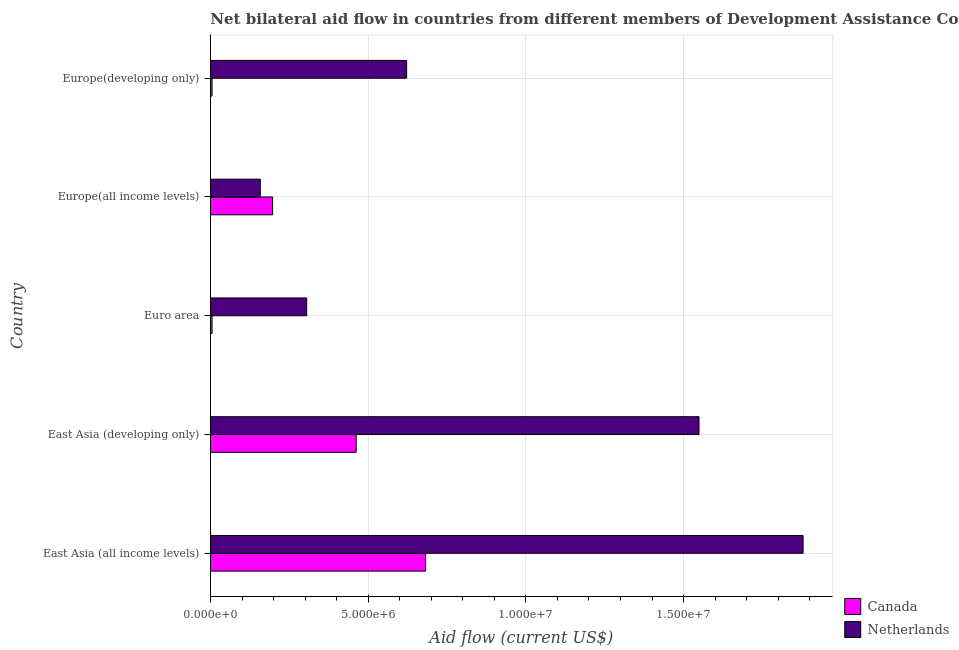How many groups of bars are there?
Offer a terse response. 5. Are the number of bars per tick equal to the number of legend labels?
Provide a succinct answer. Yes. What is the label of the 2nd group of bars from the top?
Ensure brevity in your answer.  Europe(all income levels). What is the amount of aid given by canada in Europe(all income levels)?
Your answer should be compact. 1.97e+06. Across all countries, what is the maximum amount of aid given by netherlands?
Ensure brevity in your answer.  1.88e+07. Across all countries, what is the minimum amount of aid given by netherlands?
Give a very brief answer. 1.58e+06. In which country was the amount of aid given by canada maximum?
Your response must be concise. East Asia (all income levels). In which country was the amount of aid given by netherlands minimum?
Offer a very short reply. Europe(all income levels). What is the total amount of aid given by netherlands in the graph?
Offer a very short reply. 4.51e+07. What is the difference between the amount of aid given by canada in East Asia (developing only) and that in Europe(developing only)?
Ensure brevity in your answer.  4.57e+06. What is the difference between the amount of aid given by canada in Europe(all income levels) and the amount of aid given by netherlands in East Asia (all income levels)?
Provide a short and direct response. -1.68e+07. What is the average amount of aid given by netherlands per country?
Give a very brief answer. 9.03e+06. In how many countries, is the amount of aid given by netherlands greater than 3000000 US$?
Your answer should be very brief. 4. What is the ratio of the amount of aid given by netherlands in East Asia (developing only) to that in Europe(all income levels)?
Ensure brevity in your answer.  9.8. Is the amount of aid given by canada in East Asia (all income levels) less than that in Euro area?
Provide a succinct answer. No. What is the difference between the highest and the second highest amount of aid given by canada?
Make the answer very short. 2.20e+06. What is the difference between the highest and the lowest amount of aid given by canada?
Offer a very short reply. 6.77e+06. What does the 1st bar from the top in Europe(all income levels) represents?
Offer a terse response. Netherlands. How many bars are there?
Make the answer very short. 10. How many countries are there in the graph?
Provide a succinct answer. 5. Are the values on the major ticks of X-axis written in scientific E-notation?
Make the answer very short. Yes. How many legend labels are there?
Ensure brevity in your answer.  2. How are the legend labels stacked?
Offer a terse response. Vertical. What is the title of the graph?
Your answer should be very brief. Net bilateral aid flow in countries from different members of Development Assistance Committee. What is the label or title of the X-axis?
Your answer should be very brief. Aid flow (current US$). What is the label or title of the Y-axis?
Provide a short and direct response. Country. What is the Aid flow (current US$) in Canada in East Asia (all income levels)?
Your response must be concise. 6.82e+06. What is the Aid flow (current US$) in Netherlands in East Asia (all income levels)?
Your response must be concise. 1.88e+07. What is the Aid flow (current US$) in Canada in East Asia (developing only)?
Offer a very short reply. 4.62e+06. What is the Aid flow (current US$) in Netherlands in East Asia (developing only)?
Offer a terse response. 1.55e+07. What is the Aid flow (current US$) of Canada in Euro area?
Provide a short and direct response. 5.00e+04. What is the Aid flow (current US$) in Netherlands in Euro area?
Your answer should be compact. 3.05e+06. What is the Aid flow (current US$) in Canada in Europe(all income levels)?
Give a very brief answer. 1.97e+06. What is the Aid flow (current US$) in Netherlands in Europe(all income levels)?
Keep it short and to the point. 1.58e+06. What is the Aid flow (current US$) in Netherlands in Europe(developing only)?
Your response must be concise. 6.22e+06. Across all countries, what is the maximum Aid flow (current US$) in Canada?
Keep it short and to the point. 6.82e+06. Across all countries, what is the maximum Aid flow (current US$) in Netherlands?
Offer a terse response. 1.88e+07. Across all countries, what is the minimum Aid flow (current US$) in Netherlands?
Offer a terse response. 1.58e+06. What is the total Aid flow (current US$) of Canada in the graph?
Your response must be concise. 1.35e+07. What is the total Aid flow (current US$) in Netherlands in the graph?
Your answer should be very brief. 4.51e+07. What is the difference between the Aid flow (current US$) in Canada in East Asia (all income levels) and that in East Asia (developing only)?
Your answer should be compact. 2.20e+06. What is the difference between the Aid flow (current US$) in Netherlands in East Asia (all income levels) and that in East Asia (developing only)?
Provide a succinct answer. 3.30e+06. What is the difference between the Aid flow (current US$) in Canada in East Asia (all income levels) and that in Euro area?
Offer a terse response. 6.77e+06. What is the difference between the Aid flow (current US$) in Netherlands in East Asia (all income levels) and that in Euro area?
Offer a very short reply. 1.57e+07. What is the difference between the Aid flow (current US$) in Canada in East Asia (all income levels) and that in Europe(all income levels)?
Offer a terse response. 4.85e+06. What is the difference between the Aid flow (current US$) of Netherlands in East Asia (all income levels) and that in Europe(all income levels)?
Your response must be concise. 1.72e+07. What is the difference between the Aid flow (current US$) in Canada in East Asia (all income levels) and that in Europe(developing only)?
Give a very brief answer. 6.77e+06. What is the difference between the Aid flow (current US$) in Netherlands in East Asia (all income levels) and that in Europe(developing only)?
Offer a very short reply. 1.26e+07. What is the difference between the Aid flow (current US$) in Canada in East Asia (developing only) and that in Euro area?
Your response must be concise. 4.57e+06. What is the difference between the Aid flow (current US$) of Netherlands in East Asia (developing only) and that in Euro area?
Provide a short and direct response. 1.24e+07. What is the difference between the Aid flow (current US$) in Canada in East Asia (developing only) and that in Europe(all income levels)?
Make the answer very short. 2.65e+06. What is the difference between the Aid flow (current US$) of Netherlands in East Asia (developing only) and that in Europe(all income levels)?
Offer a terse response. 1.39e+07. What is the difference between the Aid flow (current US$) in Canada in East Asia (developing only) and that in Europe(developing only)?
Ensure brevity in your answer.  4.57e+06. What is the difference between the Aid flow (current US$) of Netherlands in East Asia (developing only) and that in Europe(developing only)?
Your response must be concise. 9.27e+06. What is the difference between the Aid flow (current US$) in Canada in Euro area and that in Europe(all income levels)?
Offer a very short reply. -1.92e+06. What is the difference between the Aid flow (current US$) in Netherlands in Euro area and that in Europe(all income levels)?
Offer a terse response. 1.47e+06. What is the difference between the Aid flow (current US$) in Canada in Euro area and that in Europe(developing only)?
Offer a terse response. 0. What is the difference between the Aid flow (current US$) of Netherlands in Euro area and that in Europe(developing only)?
Your response must be concise. -3.17e+06. What is the difference between the Aid flow (current US$) in Canada in Europe(all income levels) and that in Europe(developing only)?
Make the answer very short. 1.92e+06. What is the difference between the Aid flow (current US$) in Netherlands in Europe(all income levels) and that in Europe(developing only)?
Offer a terse response. -4.64e+06. What is the difference between the Aid flow (current US$) of Canada in East Asia (all income levels) and the Aid flow (current US$) of Netherlands in East Asia (developing only)?
Your answer should be compact. -8.67e+06. What is the difference between the Aid flow (current US$) in Canada in East Asia (all income levels) and the Aid flow (current US$) in Netherlands in Euro area?
Provide a succinct answer. 3.77e+06. What is the difference between the Aid flow (current US$) in Canada in East Asia (all income levels) and the Aid flow (current US$) in Netherlands in Europe(all income levels)?
Your answer should be very brief. 5.24e+06. What is the difference between the Aid flow (current US$) of Canada in East Asia (all income levels) and the Aid flow (current US$) of Netherlands in Europe(developing only)?
Make the answer very short. 6.00e+05. What is the difference between the Aid flow (current US$) in Canada in East Asia (developing only) and the Aid flow (current US$) in Netherlands in Euro area?
Provide a short and direct response. 1.57e+06. What is the difference between the Aid flow (current US$) of Canada in East Asia (developing only) and the Aid flow (current US$) of Netherlands in Europe(all income levels)?
Give a very brief answer. 3.04e+06. What is the difference between the Aid flow (current US$) in Canada in East Asia (developing only) and the Aid flow (current US$) in Netherlands in Europe(developing only)?
Your answer should be very brief. -1.60e+06. What is the difference between the Aid flow (current US$) of Canada in Euro area and the Aid flow (current US$) of Netherlands in Europe(all income levels)?
Your answer should be compact. -1.53e+06. What is the difference between the Aid flow (current US$) in Canada in Euro area and the Aid flow (current US$) in Netherlands in Europe(developing only)?
Give a very brief answer. -6.17e+06. What is the difference between the Aid flow (current US$) in Canada in Europe(all income levels) and the Aid flow (current US$) in Netherlands in Europe(developing only)?
Make the answer very short. -4.25e+06. What is the average Aid flow (current US$) of Canada per country?
Ensure brevity in your answer.  2.70e+06. What is the average Aid flow (current US$) in Netherlands per country?
Make the answer very short. 9.03e+06. What is the difference between the Aid flow (current US$) of Canada and Aid flow (current US$) of Netherlands in East Asia (all income levels)?
Make the answer very short. -1.20e+07. What is the difference between the Aid flow (current US$) in Canada and Aid flow (current US$) in Netherlands in East Asia (developing only)?
Provide a short and direct response. -1.09e+07. What is the difference between the Aid flow (current US$) in Canada and Aid flow (current US$) in Netherlands in Euro area?
Keep it short and to the point. -3.00e+06. What is the difference between the Aid flow (current US$) in Canada and Aid flow (current US$) in Netherlands in Europe(all income levels)?
Offer a very short reply. 3.90e+05. What is the difference between the Aid flow (current US$) of Canada and Aid flow (current US$) of Netherlands in Europe(developing only)?
Your answer should be compact. -6.17e+06. What is the ratio of the Aid flow (current US$) in Canada in East Asia (all income levels) to that in East Asia (developing only)?
Provide a succinct answer. 1.48. What is the ratio of the Aid flow (current US$) of Netherlands in East Asia (all income levels) to that in East Asia (developing only)?
Ensure brevity in your answer.  1.21. What is the ratio of the Aid flow (current US$) in Canada in East Asia (all income levels) to that in Euro area?
Provide a succinct answer. 136.4. What is the ratio of the Aid flow (current US$) in Netherlands in East Asia (all income levels) to that in Euro area?
Offer a very short reply. 6.16. What is the ratio of the Aid flow (current US$) in Canada in East Asia (all income levels) to that in Europe(all income levels)?
Offer a terse response. 3.46. What is the ratio of the Aid flow (current US$) of Netherlands in East Asia (all income levels) to that in Europe(all income levels)?
Provide a succinct answer. 11.89. What is the ratio of the Aid flow (current US$) of Canada in East Asia (all income levels) to that in Europe(developing only)?
Give a very brief answer. 136.4. What is the ratio of the Aid flow (current US$) in Netherlands in East Asia (all income levels) to that in Europe(developing only)?
Make the answer very short. 3.02. What is the ratio of the Aid flow (current US$) in Canada in East Asia (developing only) to that in Euro area?
Give a very brief answer. 92.4. What is the ratio of the Aid flow (current US$) in Netherlands in East Asia (developing only) to that in Euro area?
Make the answer very short. 5.08. What is the ratio of the Aid flow (current US$) of Canada in East Asia (developing only) to that in Europe(all income levels)?
Give a very brief answer. 2.35. What is the ratio of the Aid flow (current US$) of Netherlands in East Asia (developing only) to that in Europe(all income levels)?
Provide a short and direct response. 9.8. What is the ratio of the Aid flow (current US$) of Canada in East Asia (developing only) to that in Europe(developing only)?
Provide a short and direct response. 92.4. What is the ratio of the Aid flow (current US$) of Netherlands in East Asia (developing only) to that in Europe(developing only)?
Keep it short and to the point. 2.49. What is the ratio of the Aid flow (current US$) in Canada in Euro area to that in Europe(all income levels)?
Give a very brief answer. 0.03. What is the ratio of the Aid flow (current US$) of Netherlands in Euro area to that in Europe(all income levels)?
Your answer should be very brief. 1.93. What is the ratio of the Aid flow (current US$) of Canada in Euro area to that in Europe(developing only)?
Your answer should be compact. 1. What is the ratio of the Aid flow (current US$) of Netherlands in Euro area to that in Europe(developing only)?
Provide a short and direct response. 0.49. What is the ratio of the Aid flow (current US$) in Canada in Europe(all income levels) to that in Europe(developing only)?
Your response must be concise. 39.4. What is the ratio of the Aid flow (current US$) in Netherlands in Europe(all income levels) to that in Europe(developing only)?
Offer a terse response. 0.25. What is the difference between the highest and the second highest Aid flow (current US$) in Canada?
Offer a very short reply. 2.20e+06. What is the difference between the highest and the second highest Aid flow (current US$) of Netherlands?
Ensure brevity in your answer.  3.30e+06. What is the difference between the highest and the lowest Aid flow (current US$) in Canada?
Your answer should be very brief. 6.77e+06. What is the difference between the highest and the lowest Aid flow (current US$) of Netherlands?
Provide a short and direct response. 1.72e+07. 